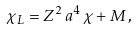Convert formula to latex. <formula><loc_0><loc_0><loc_500><loc_500>\chi _ { L } = Z ^ { 2 } \, a ^ { 4 } \, \chi + M \, ,</formula> 